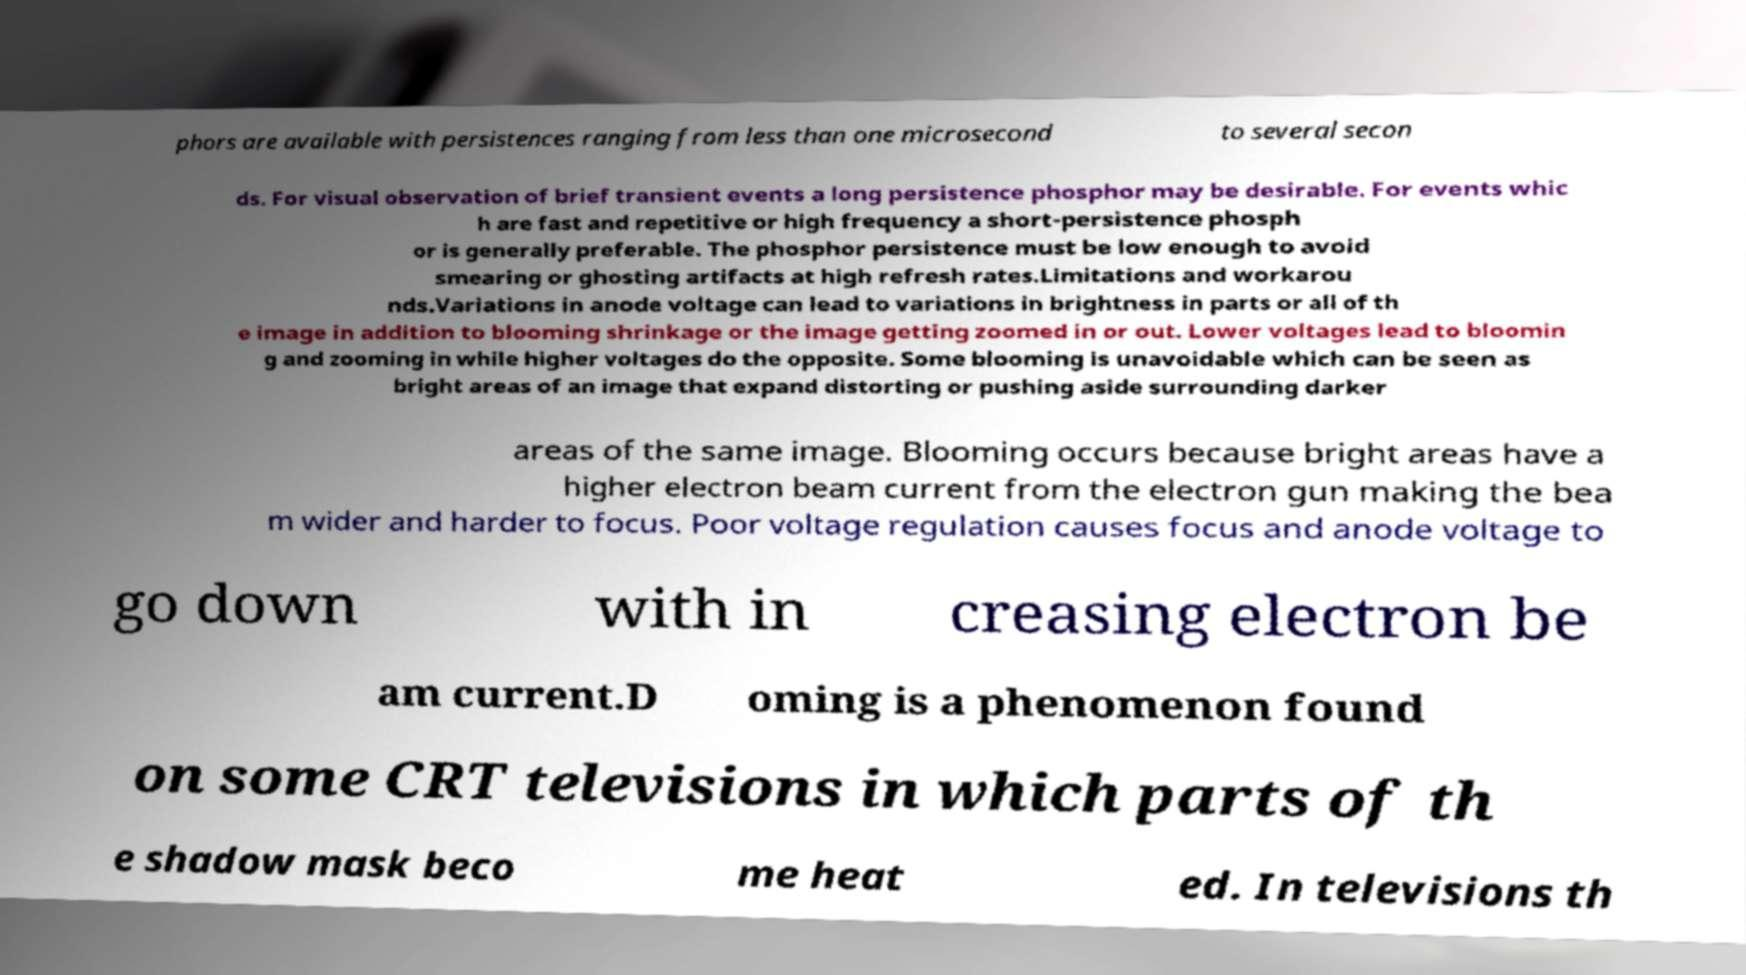What messages or text are displayed in this image? I need them in a readable, typed format. phors are available with persistences ranging from less than one microsecond to several secon ds. For visual observation of brief transient events a long persistence phosphor may be desirable. For events whic h are fast and repetitive or high frequency a short-persistence phosph or is generally preferable. The phosphor persistence must be low enough to avoid smearing or ghosting artifacts at high refresh rates.Limitations and workarou nds.Variations in anode voltage can lead to variations in brightness in parts or all of th e image in addition to blooming shrinkage or the image getting zoomed in or out. Lower voltages lead to bloomin g and zooming in while higher voltages do the opposite. Some blooming is unavoidable which can be seen as bright areas of an image that expand distorting or pushing aside surrounding darker areas of the same image. Blooming occurs because bright areas have a higher electron beam current from the electron gun making the bea m wider and harder to focus. Poor voltage regulation causes focus and anode voltage to go down with in creasing electron be am current.D oming is a phenomenon found on some CRT televisions in which parts of th e shadow mask beco me heat ed. In televisions th 